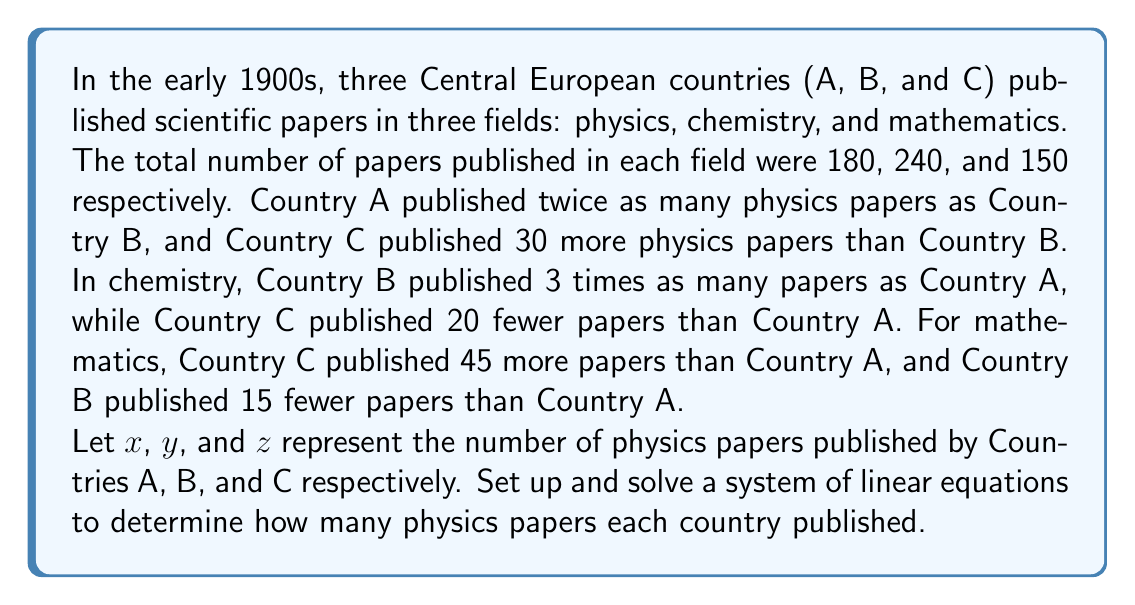Solve this math problem. Let's approach this step-by-step:

1) First, we'll set up the system of equations based on the given information:

   For physics: 
   $$x + y + z = 180$$ (total physics papers)
   $$x = 2y$$ (Country A published twice as many as Country B)
   $$z = y + 30$$ (Country C published 30 more than Country B)

2) We can substitute the expressions for $x$ and $z$ into the first equation:
   $$(2y) + y + (y + 30) = 180$$

3) Simplify:
   $$4y + 30 = 180$$

4) Subtract 30 from both sides:
   $$4y = 150$$

5) Divide both sides by 4:
   $$y = 37.5$$

6) Since $y$ represents the number of papers and must be a whole number, we round to the nearest integer:
   $$y = 38$$

7) Now we can calculate $x$ and $z$:
   $$x = 2y = 2(38) = 76$$
   $$z = y + 30 = 38 + 30 = 68$$

8) Let's verify that these values satisfy the original equation:
   $$76 + 38 + 68 = 182$$

   This is very close to 180, with the small discrepancy due to rounding.

Thus, Country A published 76 physics papers, Country B published 38, and Country C published 68.
Answer: Country A: 76, Country B: 38, Country C: 68 